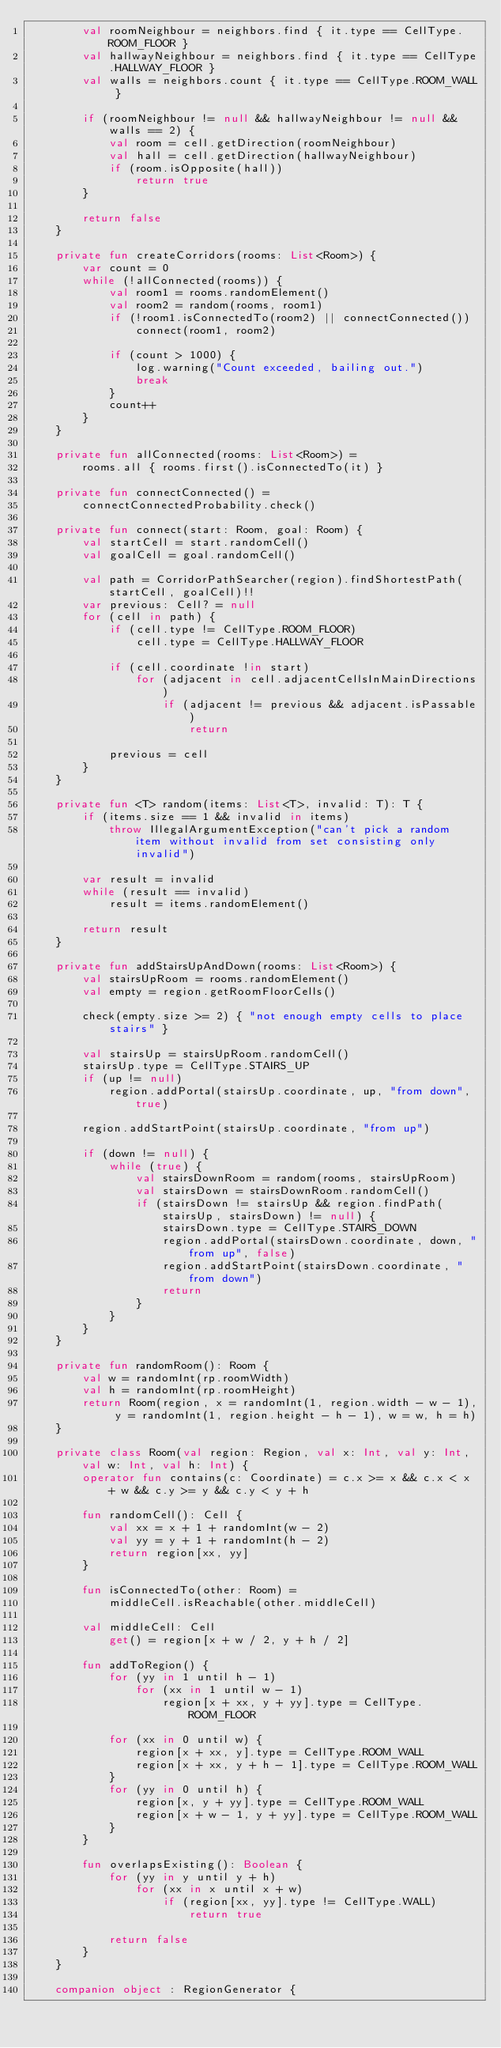Convert code to text. <code><loc_0><loc_0><loc_500><loc_500><_Kotlin_>        val roomNeighbour = neighbors.find { it.type == CellType.ROOM_FLOOR }
        val hallwayNeighbour = neighbors.find { it.type == CellType.HALLWAY_FLOOR }
        val walls = neighbors.count { it.type == CellType.ROOM_WALL }

        if (roomNeighbour != null && hallwayNeighbour != null && walls == 2) {
            val room = cell.getDirection(roomNeighbour)
            val hall = cell.getDirection(hallwayNeighbour)
            if (room.isOpposite(hall))
                return true
        }

        return false
    }

    private fun createCorridors(rooms: List<Room>) {
        var count = 0
        while (!allConnected(rooms)) {
            val room1 = rooms.randomElement()
            val room2 = random(rooms, room1)
            if (!room1.isConnectedTo(room2) || connectConnected())
                connect(room1, room2)

            if (count > 1000) {
                log.warning("Count exceeded, bailing out.")
                break
            }
            count++
        }
    }

    private fun allConnected(rooms: List<Room>) =
        rooms.all { rooms.first().isConnectedTo(it) }

    private fun connectConnected() =
        connectConnectedProbability.check()

    private fun connect(start: Room, goal: Room) {
        val startCell = start.randomCell()
        val goalCell = goal.randomCell()

        val path = CorridorPathSearcher(region).findShortestPath(startCell, goalCell)!!
        var previous: Cell? = null
        for (cell in path) {
            if (cell.type != CellType.ROOM_FLOOR)
                cell.type = CellType.HALLWAY_FLOOR

            if (cell.coordinate !in start)
                for (adjacent in cell.adjacentCellsInMainDirections)
                    if (adjacent != previous && adjacent.isPassable)
                        return

            previous = cell
        }
    }

    private fun <T> random(items: List<T>, invalid: T): T {
        if (items.size == 1 && invalid in items)
            throw IllegalArgumentException("can't pick a random item without invalid from set consisting only invalid")

        var result = invalid
        while (result == invalid)
            result = items.randomElement()

        return result
    }

    private fun addStairsUpAndDown(rooms: List<Room>) {
        val stairsUpRoom = rooms.randomElement()
        val empty = region.getRoomFloorCells()

        check(empty.size >= 2) { "not enough empty cells to place stairs" }

        val stairsUp = stairsUpRoom.randomCell()
        stairsUp.type = CellType.STAIRS_UP
        if (up != null)
            region.addPortal(stairsUp.coordinate, up, "from down", true)

        region.addStartPoint(stairsUp.coordinate, "from up")

        if (down != null) {
            while (true) {
                val stairsDownRoom = random(rooms, stairsUpRoom)
                val stairsDown = stairsDownRoom.randomCell()
                if (stairsDown != stairsUp && region.findPath(stairsUp, stairsDown) != null) {
                    stairsDown.type = CellType.STAIRS_DOWN
                    region.addPortal(stairsDown.coordinate, down, "from up", false)
                    region.addStartPoint(stairsDown.coordinate, "from down")
                    return
                }
            }
        }
    }

    private fun randomRoom(): Room {
        val w = randomInt(rp.roomWidth)
        val h = randomInt(rp.roomHeight)
        return Room(region, x = randomInt(1, region.width - w - 1), y = randomInt(1, region.height - h - 1), w = w, h = h)
    }

    private class Room(val region: Region, val x: Int, val y: Int, val w: Int, val h: Int) {
        operator fun contains(c: Coordinate) = c.x >= x && c.x < x + w && c.y >= y && c.y < y + h

        fun randomCell(): Cell {
            val xx = x + 1 + randomInt(w - 2)
            val yy = y + 1 + randomInt(h - 2)
            return region[xx, yy]
        }

        fun isConnectedTo(other: Room) =
            middleCell.isReachable(other.middleCell)

        val middleCell: Cell
            get() = region[x + w / 2, y + h / 2]

        fun addToRegion() {
            for (yy in 1 until h - 1)
                for (xx in 1 until w - 1)
                    region[x + xx, y + yy].type = CellType.ROOM_FLOOR

            for (xx in 0 until w) {
                region[x + xx, y].type = CellType.ROOM_WALL
                region[x + xx, y + h - 1].type = CellType.ROOM_WALL
            }
            for (yy in 0 until h) {
                region[x, y + yy].type = CellType.ROOM_WALL
                region[x + w - 1, y + yy].type = CellType.ROOM_WALL
            }
        }

        fun overlapsExisting(): Boolean {
            for (yy in y until y + h)
                for (xx in x until x + w)
                    if (region[xx, yy].type != CellType.WALL)
                        return true

            return false
        }
    }

    companion object : RegionGenerator {</code> 